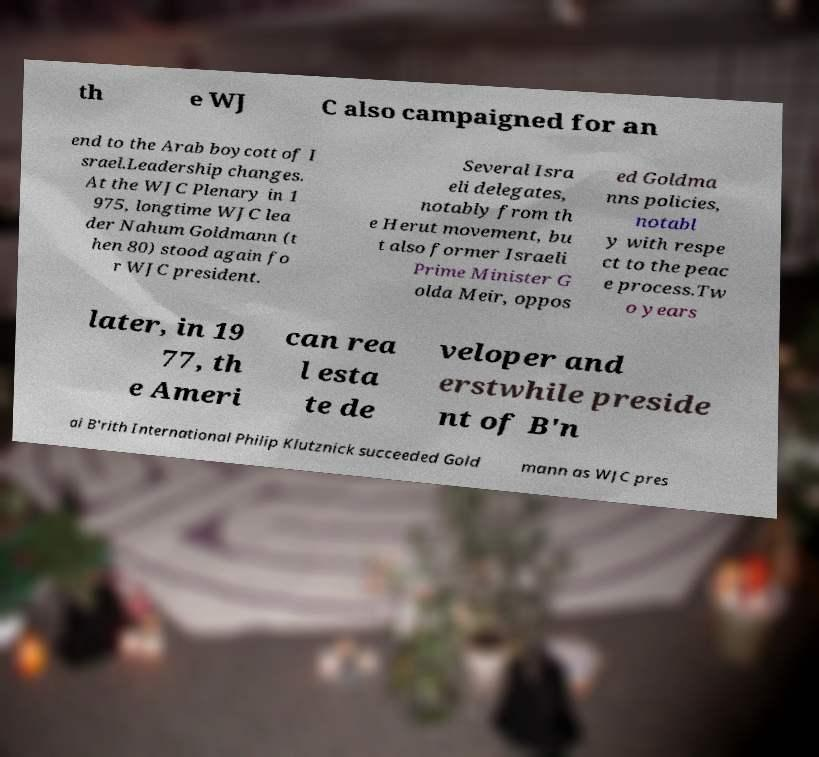What messages or text are displayed in this image? I need them in a readable, typed format. th e WJ C also campaigned for an end to the Arab boycott of I srael.Leadership changes. At the WJC Plenary in 1 975, longtime WJC lea der Nahum Goldmann (t hen 80) stood again fo r WJC president. Several Isra eli delegates, notably from th e Herut movement, bu t also former Israeli Prime Minister G olda Meir, oppos ed Goldma nns policies, notabl y with respe ct to the peac e process.Tw o years later, in 19 77, th e Ameri can rea l esta te de veloper and erstwhile preside nt of B'n ai B'rith International Philip Klutznick succeeded Gold mann as WJC pres 